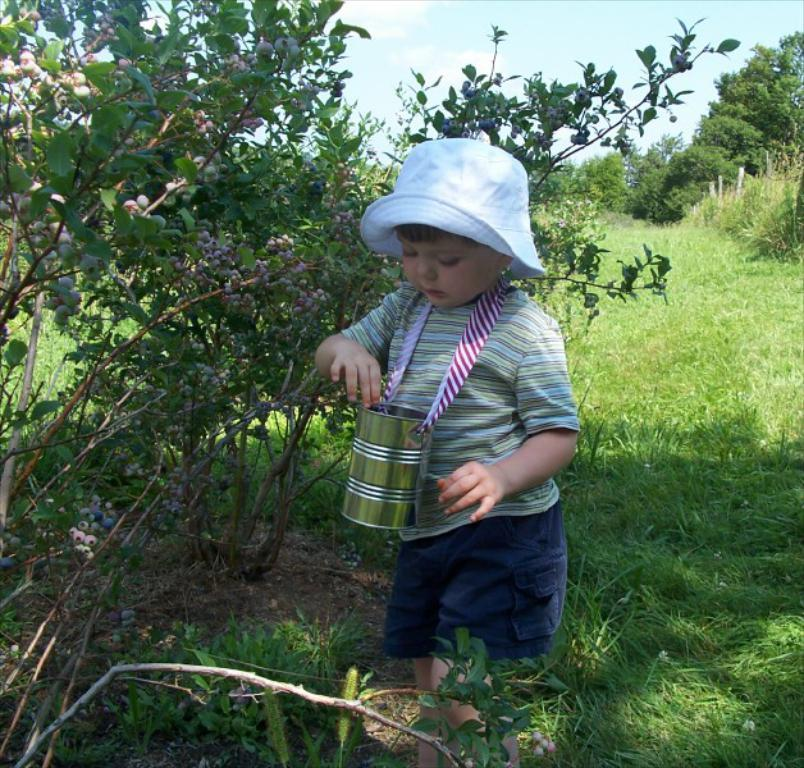What is the child in the image wearing on their head? The child in the image is wearing a cap. What type of container is present in the image? There is a steel jar in the image. What type of vegetation can be seen in the image? Trees and grass are visible in the image. What can be seen in the background of the image? The sky with clouds is visible in the background of the image. How many boats are visible in the image? There are no boats present in the image. What type of motion is the child experiencing in the image? The image does not depict any motion; the child is stationary. 